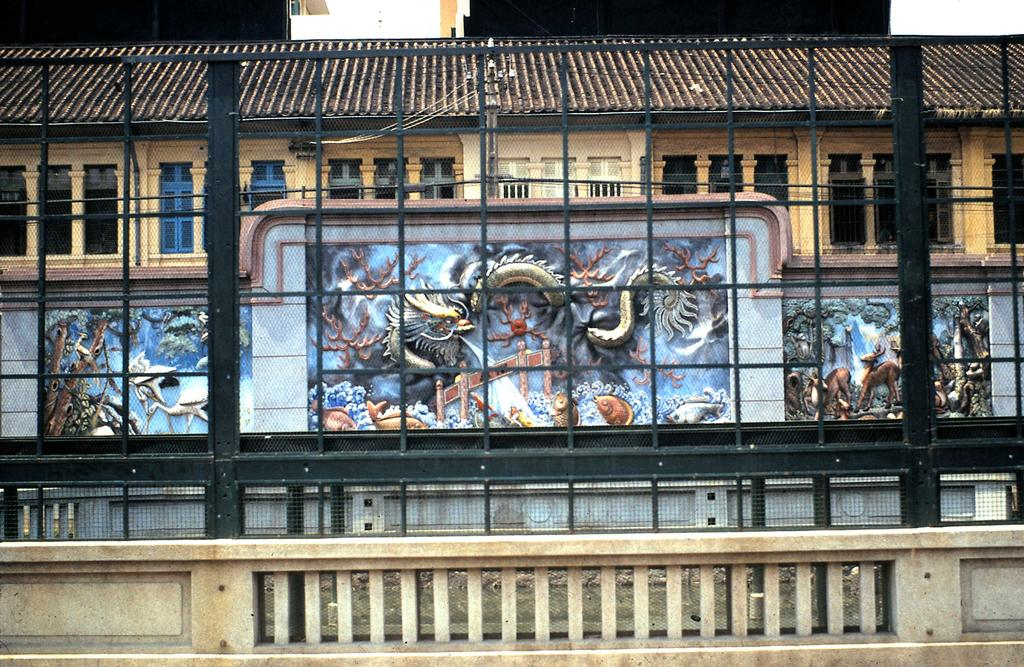What type of structures can be seen in the image? There are buildings in the image. What feature do the buildings have? The buildings have windows. What type of barrier is visible in the image? There is a fence in the image. What type of decorative elements are present in the image? Carved sculptures are present in the image. What type of copper material can be seen in the image? There is no copper material present in the image. How many eyes can be seen on the kitty in the image? There is no kitty present in the image. 